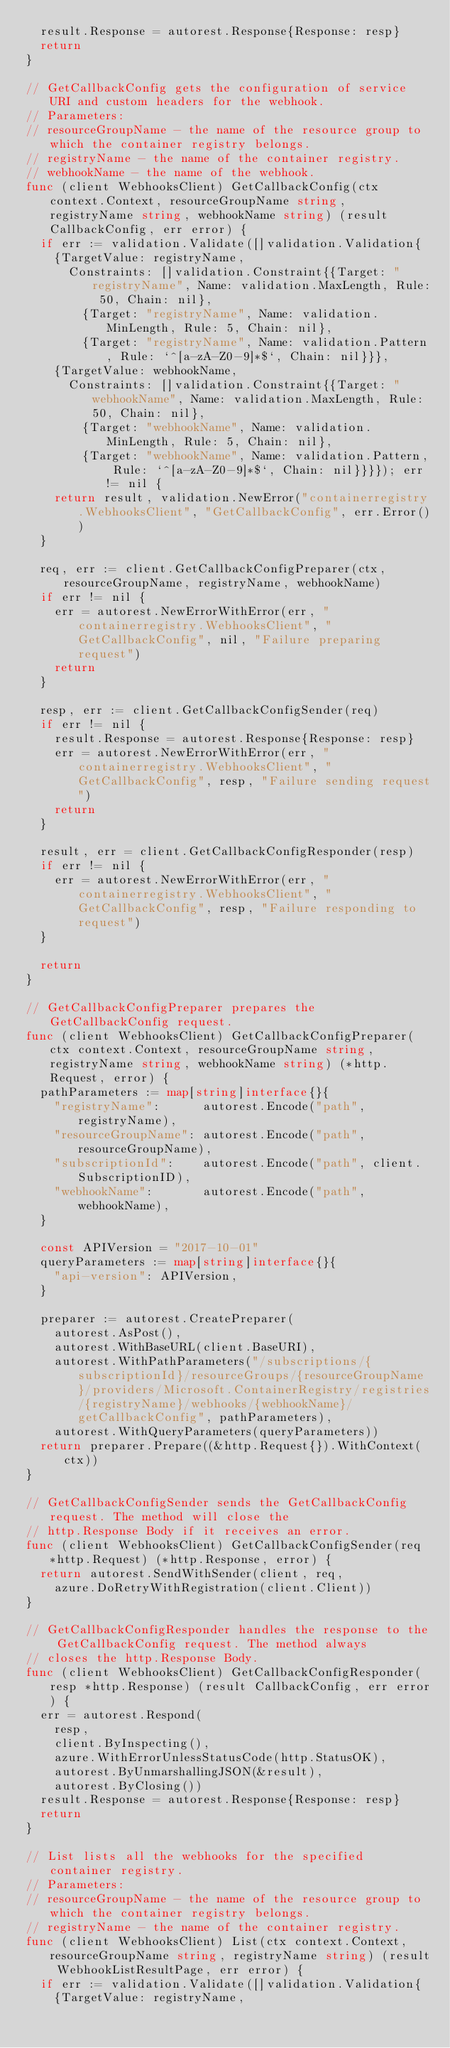<code> <loc_0><loc_0><loc_500><loc_500><_Go_>	result.Response = autorest.Response{Response: resp}
	return
}

// GetCallbackConfig gets the configuration of service URI and custom headers for the webhook.
// Parameters:
// resourceGroupName - the name of the resource group to which the container registry belongs.
// registryName - the name of the container registry.
// webhookName - the name of the webhook.
func (client WebhooksClient) GetCallbackConfig(ctx context.Context, resourceGroupName string, registryName string, webhookName string) (result CallbackConfig, err error) {
	if err := validation.Validate([]validation.Validation{
		{TargetValue: registryName,
			Constraints: []validation.Constraint{{Target: "registryName", Name: validation.MaxLength, Rule: 50, Chain: nil},
				{Target: "registryName", Name: validation.MinLength, Rule: 5, Chain: nil},
				{Target: "registryName", Name: validation.Pattern, Rule: `^[a-zA-Z0-9]*$`, Chain: nil}}},
		{TargetValue: webhookName,
			Constraints: []validation.Constraint{{Target: "webhookName", Name: validation.MaxLength, Rule: 50, Chain: nil},
				{Target: "webhookName", Name: validation.MinLength, Rule: 5, Chain: nil},
				{Target: "webhookName", Name: validation.Pattern, Rule: `^[a-zA-Z0-9]*$`, Chain: nil}}}}); err != nil {
		return result, validation.NewError("containerregistry.WebhooksClient", "GetCallbackConfig", err.Error())
	}

	req, err := client.GetCallbackConfigPreparer(ctx, resourceGroupName, registryName, webhookName)
	if err != nil {
		err = autorest.NewErrorWithError(err, "containerregistry.WebhooksClient", "GetCallbackConfig", nil, "Failure preparing request")
		return
	}

	resp, err := client.GetCallbackConfigSender(req)
	if err != nil {
		result.Response = autorest.Response{Response: resp}
		err = autorest.NewErrorWithError(err, "containerregistry.WebhooksClient", "GetCallbackConfig", resp, "Failure sending request")
		return
	}

	result, err = client.GetCallbackConfigResponder(resp)
	if err != nil {
		err = autorest.NewErrorWithError(err, "containerregistry.WebhooksClient", "GetCallbackConfig", resp, "Failure responding to request")
	}

	return
}

// GetCallbackConfigPreparer prepares the GetCallbackConfig request.
func (client WebhooksClient) GetCallbackConfigPreparer(ctx context.Context, resourceGroupName string, registryName string, webhookName string) (*http.Request, error) {
	pathParameters := map[string]interface{}{
		"registryName":      autorest.Encode("path", registryName),
		"resourceGroupName": autorest.Encode("path", resourceGroupName),
		"subscriptionId":    autorest.Encode("path", client.SubscriptionID),
		"webhookName":       autorest.Encode("path", webhookName),
	}

	const APIVersion = "2017-10-01"
	queryParameters := map[string]interface{}{
		"api-version": APIVersion,
	}

	preparer := autorest.CreatePreparer(
		autorest.AsPost(),
		autorest.WithBaseURL(client.BaseURI),
		autorest.WithPathParameters("/subscriptions/{subscriptionId}/resourceGroups/{resourceGroupName}/providers/Microsoft.ContainerRegistry/registries/{registryName}/webhooks/{webhookName}/getCallbackConfig", pathParameters),
		autorest.WithQueryParameters(queryParameters))
	return preparer.Prepare((&http.Request{}).WithContext(ctx))
}

// GetCallbackConfigSender sends the GetCallbackConfig request. The method will close the
// http.Response Body if it receives an error.
func (client WebhooksClient) GetCallbackConfigSender(req *http.Request) (*http.Response, error) {
	return autorest.SendWithSender(client, req,
		azure.DoRetryWithRegistration(client.Client))
}

// GetCallbackConfigResponder handles the response to the GetCallbackConfig request. The method always
// closes the http.Response Body.
func (client WebhooksClient) GetCallbackConfigResponder(resp *http.Response) (result CallbackConfig, err error) {
	err = autorest.Respond(
		resp,
		client.ByInspecting(),
		azure.WithErrorUnlessStatusCode(http.StatusOK),
		autorest.ByUnmarshallingJSON(&result),
		autorest.ByClosing())
	result.Response = autorest.Response{Response: resp}
	return
}

// List lists all the webhooks for the specified container registry.
// Parameters:
// resourceGroupName - the name of the resource group to which the container registry belongs.
// registryName - the name of the container registry.
func (client WebhooksClient) List(ctx context.Context, resourceGroupName string, registryName string) (result WebhookListResultPage, err error) {
	if err := validation.Validate([]validation.Validation{
		{TargetValue: registryName,</code> 